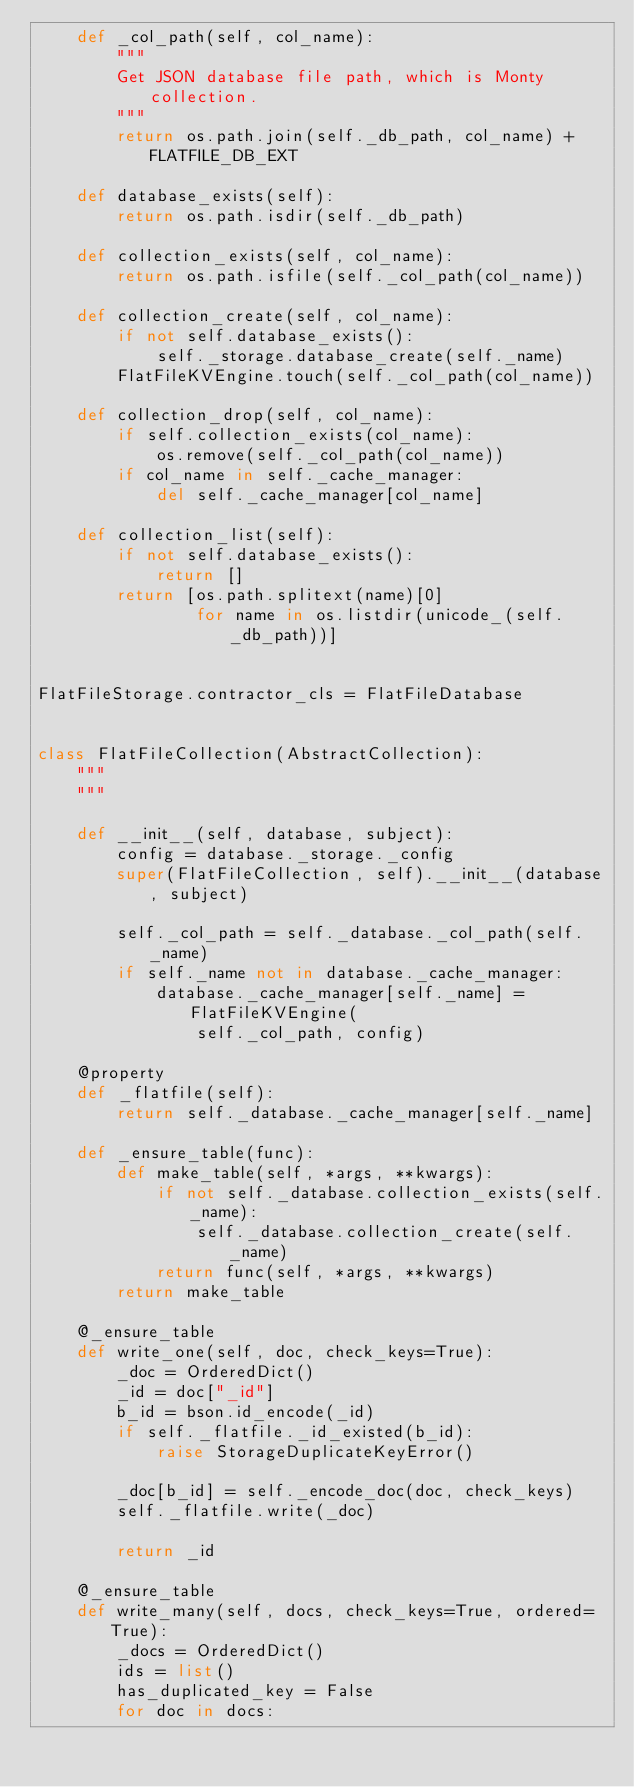<code> <loc_0><loc_0><loc_500><loc_500><_Python_>    def _col_path(self, col_name):
        """
        Get JSON database file path, which is Monty collection.
        """
        return os.path.join(self._db_path, col_name) + FLATFILE_DB_EXT

    def database_exists(self):
        return os.path.isdir(self._db_path)

    def collection_exists(self, col_name):
        return os.path.isfile(self._col_path(col_name))

    def collection_create(self, col_name):
        if not self.database_exists():
            self._storage.database_create(self._name)
        FlatFileKVEngine.touch(self._col_path(col_name))

    def collection_drop(self, col_name):
        if self.collection_exists(col_name):
            os.remove(self._col_path(col_name))
        if col_name in self._cache_manager:
            del self._cache_manager[col_name]

    def collection_list(self):
        if not self.database_exists():
            return []
        return [os.path.splitext(name)[0]
                for name in os.listdir(unicode_(self._db_path))]


FlatFileStorage.contractor_cls = FlatFileDatabase


class FlatFileCollection(AbstractCollection):
    """
    """

    def __init__(self, database, subject):
        config = database._storage._config
        super(FlatFileCollection, self).__init__(database, subject)

        self._col_path = self._database._col_path(self._name)
        if self._name not in database._cache_manager:
            database._cache_manager[self._name] = FlatFileKVEngine(
                self._col_path, config)

    @property
    def _flatfile(self):
        return self._database._cache_manager[self._name]

    def _ensure_table(func):
        def make_table(self, *args, **kwargs):
            if not self._database.collection_exists(self._name):
                self._database.collection_create(self._name)
            return func(self, *args, **kwargs)
        return make_table

    @_ensure_table
    def write_one(self, doc, check_keys=True):
        _doc = OrderedDict()
        _id = doc["_id"]
        b_id = bson.id_encode(_id)
        if self._flatfile._id_existed(b_id):
            raise StorageDuplicateKeyError()

        _doc[b_id] = self._encode_doc(doc, check_keys)
        self._flatfile.write(_doc)

        return _id

    @_ensure_table
    def write_many(self, docs, check_keys=True, ordered=True):
        _docs = OrderedDict()
        ids = list()
        has_duplicated_key = False
        for doc in docs:</code> 